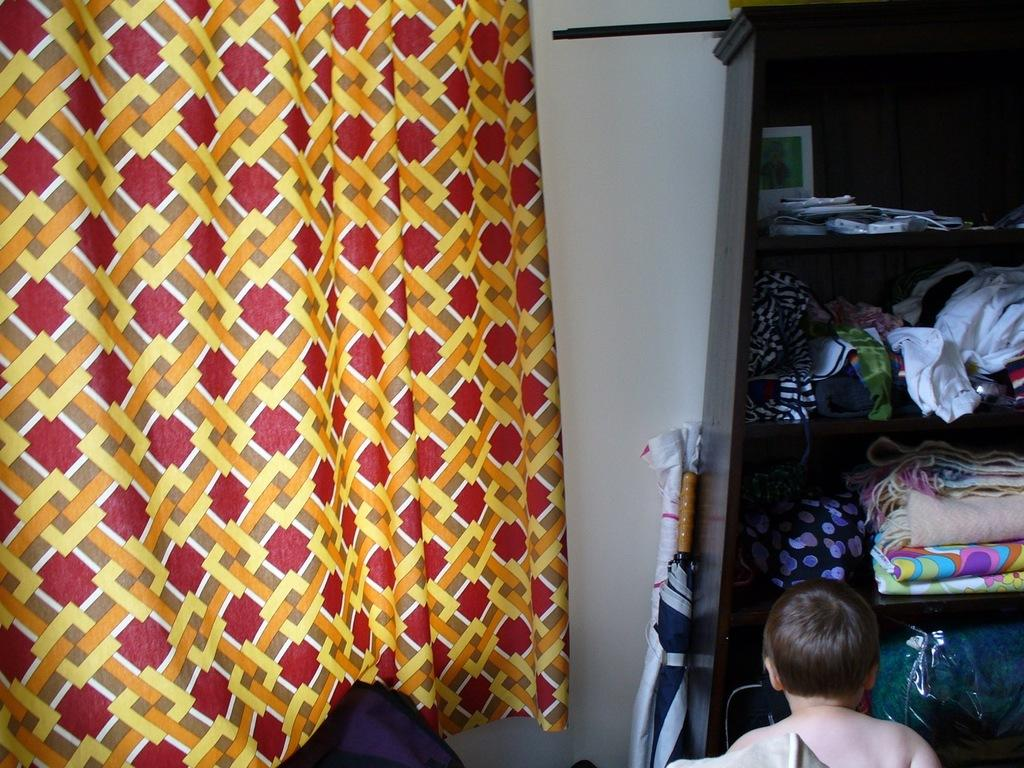What type of covering is visible in the image? There is a curtain in the image. What is on the shelf in the image? There is a shelf with clothes in the image. Who is present in the image? A boy is present in the image. Where is the boy located in relation to the shelf? The boy is in front of the shelf. What type of wire is the boy holding in the image? There is no wire present in the image. How many snails can be seen on the shelf with clothes in the image? There are no snails present in the image. 